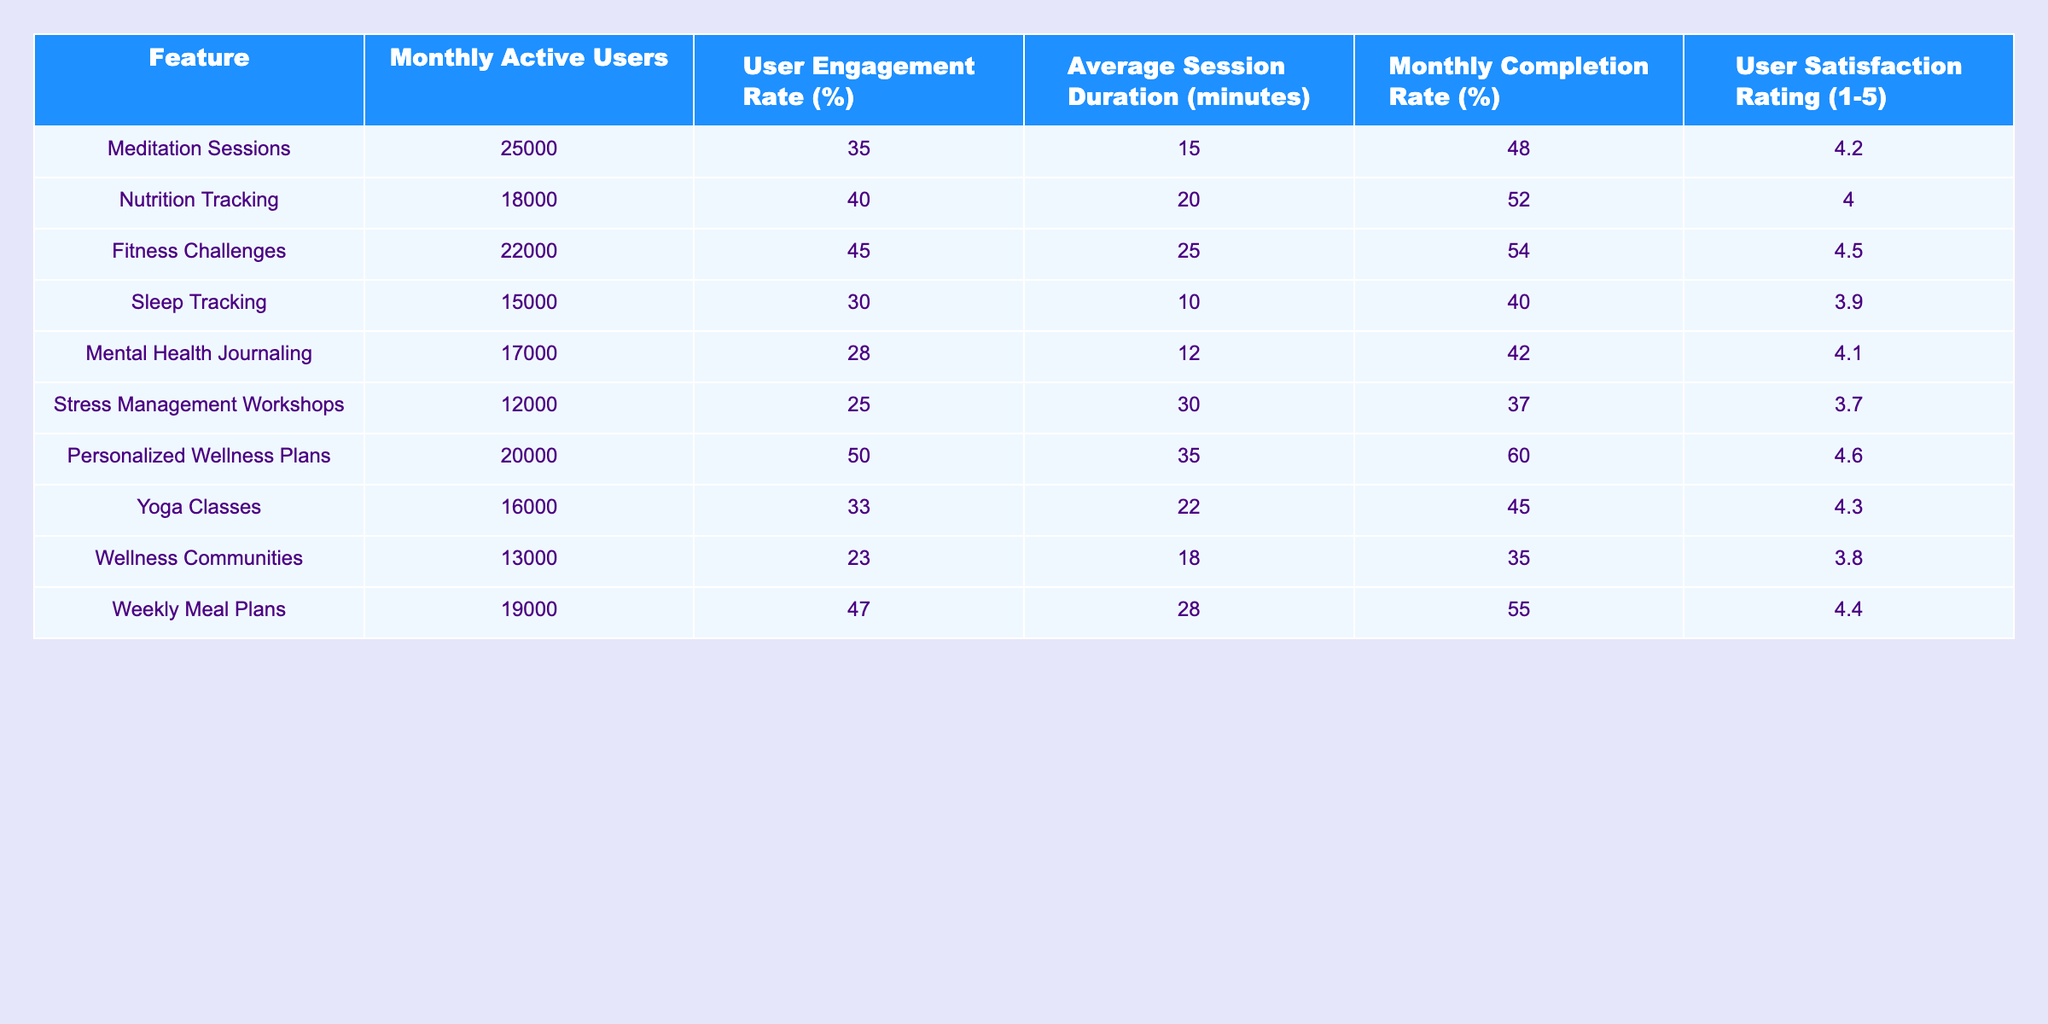What is the User Satisfaction Rating for the Nutrition Tracking feature? From the table, the User Satisfaction Rating for Nutrition Tracking is listed under the corresponding column, which shows a value of 4.0.
Answer: 4.0 Which feature has the highest Monthly Completion Rate? By reviewing the Monthly Completion Rate column, we can identify that Personalized Wellness Plans have the highest completion rate of 60%.
Answer: 60% How many Monthly Active Users does the Sleep Tracking feature have? The Monthly Active Users for Sleep Tracking is directly indicated in the relevant column of the table, showing a total of 15,000 users.
Answer: 15000 What is the Average Session Duration for Fitness Challenges? The table lists the Average Session Duration for Fitness Challenges as 25 minutes in the specified column.
Answer: 25 Which feature has a lower User Engagement Rate: Mental Health Journaling or Sleep Tracking? Mental Health Journaling has a User Engagement Rate of 28%, while Sleep Tracking has 30%. Since 28% is less than 30%, Mental Health Journaling has the lower rate.
Answer: Mental Health Journaling Calculate the average User Satisfaction Rating for features with over 20,000 Monthly Active Users. The features with over 20,000 Monthly Active Users are Meditation Sessions (4.2), Fitness Challenges (4.5), and Personalized Wellness Plans (4.6). The sum is (4.2 + 4.5 + 4.6) = 13.3, and there are 3 features, so the average User Satisfaction Rating is 13.3 / 3 = 4.43.
Answer: 4.43 Is the Average Session Duration for Yoga Classes higher than that of Stress Management Workshops? The Average Session Duration for Yoga Classes is 22 minutes, while for Stress Management Workshops, it's 30 minutes. Since 22 is less than 30, the statement is false.
Answer: No Which feature has the highest difference between Monthly Active Users and User Engagement Rate? To find the difference, we can examine Monthly Active Users and User Engagement Rate for each feature. Calculating the difference for each: Meditation Sessions (25000 - 35), Nutrition Tracking (18000 - 40), etc. The highest difference can be found to be for Fitness Challenges: 22000 (users) - 45 (engagement rate) = 21955, making it the highest.
Answer: Fitness Challenges What is the total number of Monthly Active Users for features with a User Satisfaction Rating above 4? The features with a User Satisfaction Rating above 4 are Meditation Sessions, Fitness Challenges, Personalized Wellness Plans, Yoga Classes, and Weekly Meal Plans. Adding their Monthly Active Users: 25000 + 22000 + 20000 + 16000 + 19000 = 102000.
Answer: 102000 For which feature does the User Satisfaction Rating closely align with the User Engagement Rate? By examining both ratings, we observe that the User Satisfaction Rating for Yoga Classes (4.3) and the User Engagement Rate (33%) are relatively closer compared to other features.
Answer: Yoga Classes 